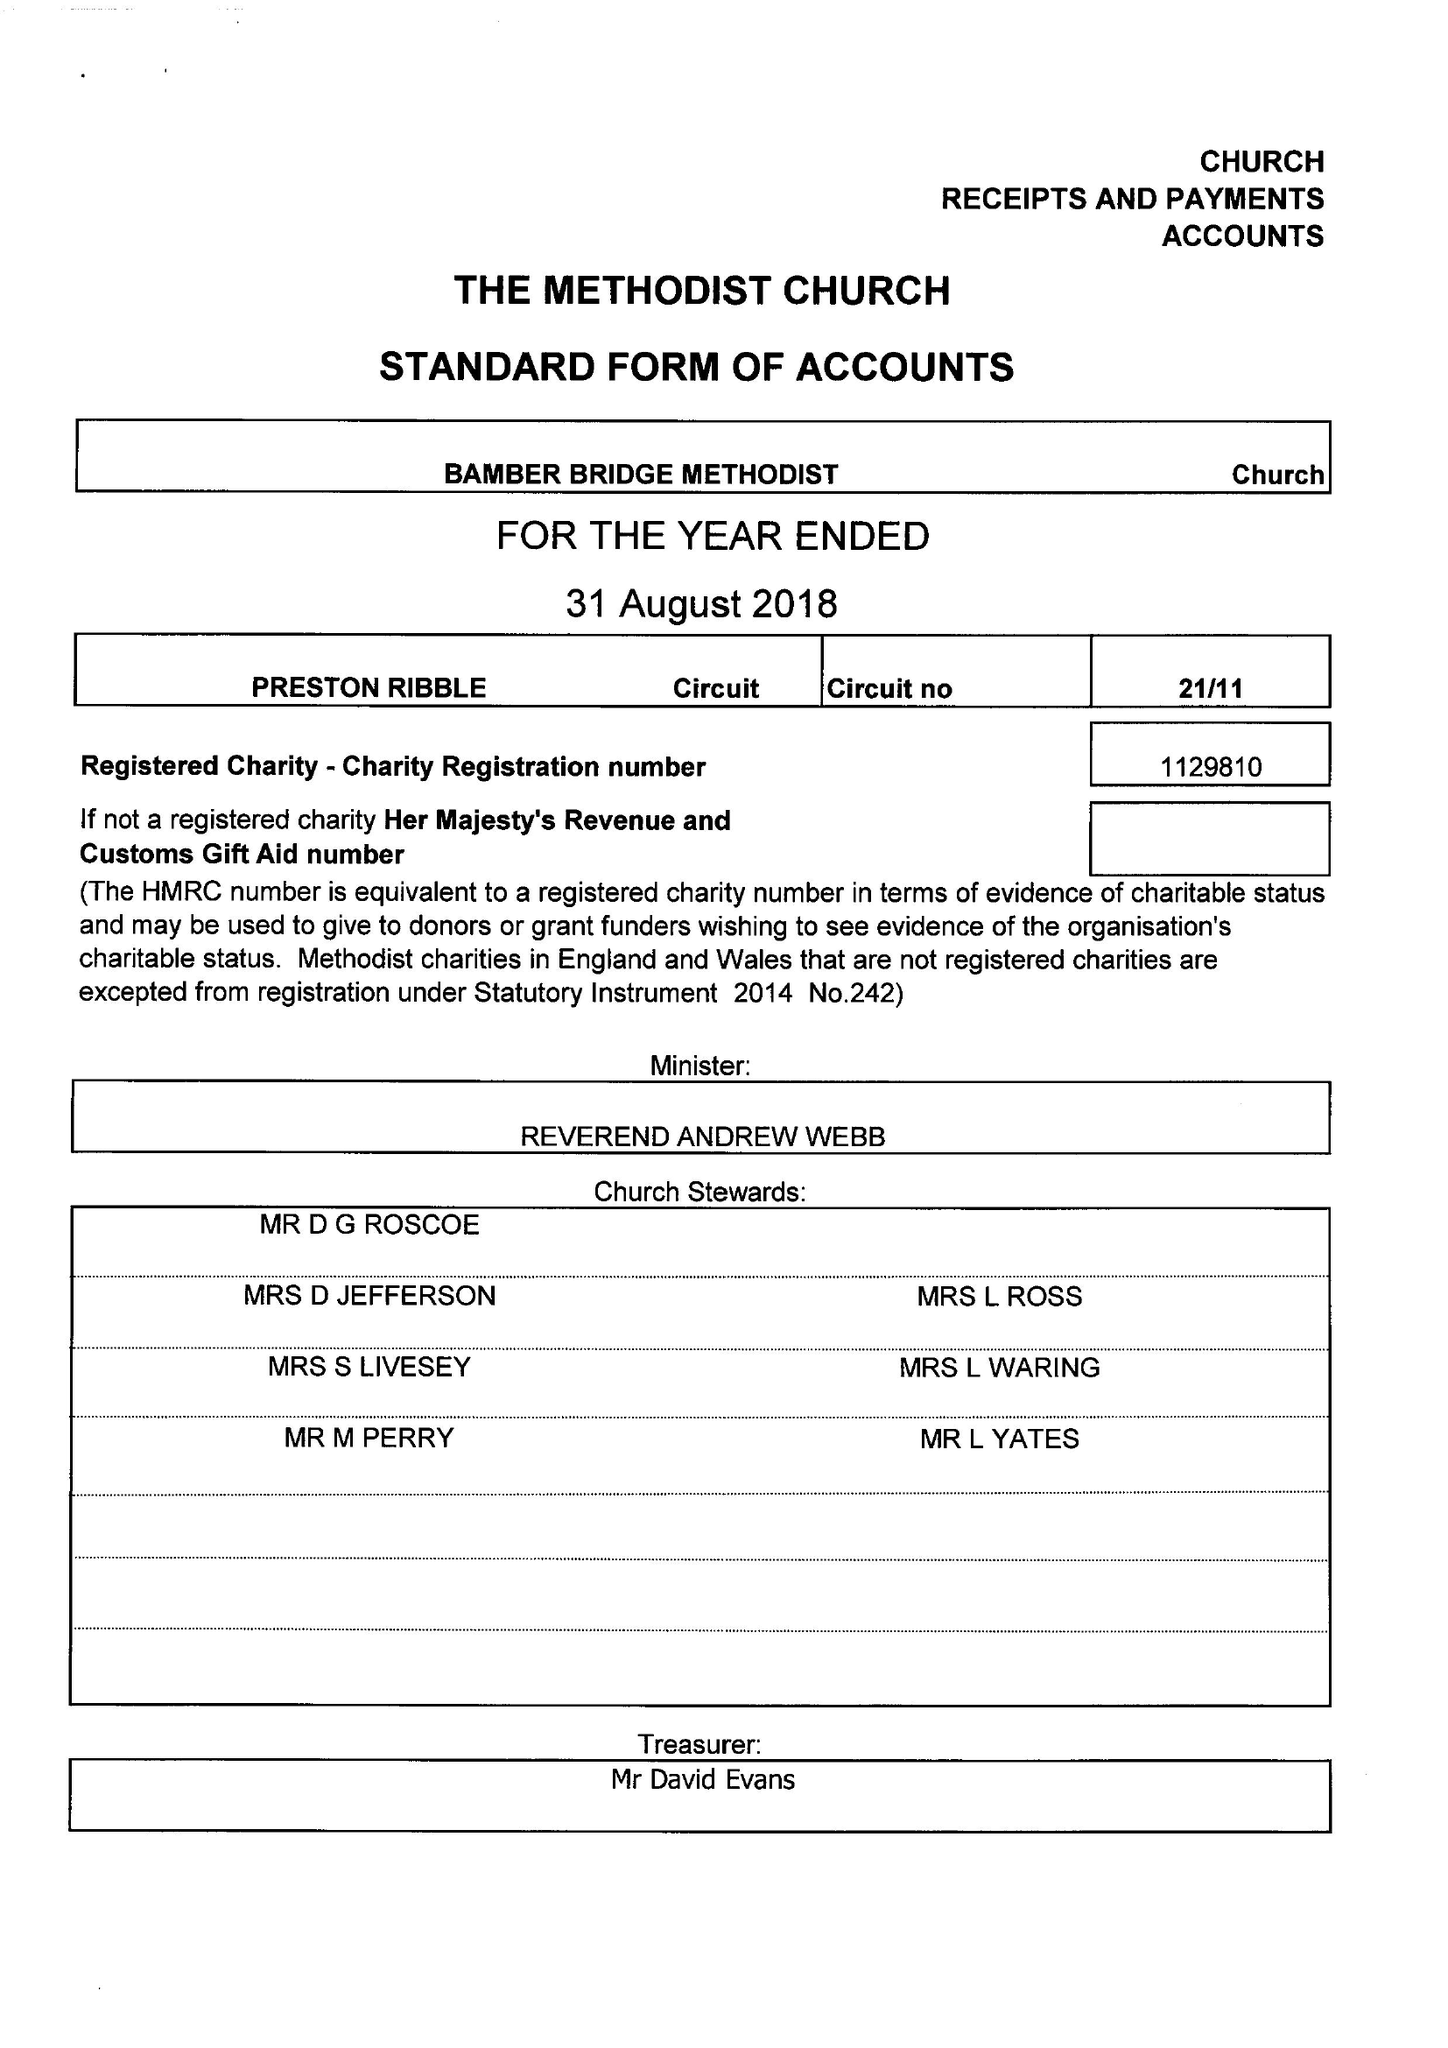What is the value for the charity_name?
Answer the question using a single word or phrase. Bamber Bridge Methodist Church 